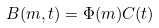Convert formula to latex. <formula><loc_0><loc_0><loc_500><loc_500>B ( m , t ) = \Phi ( m ) C ( t )</formula> 